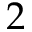Convert formula to latex. <formula><loc_0><loc_0><loc_500><loc_500>2</formula> 